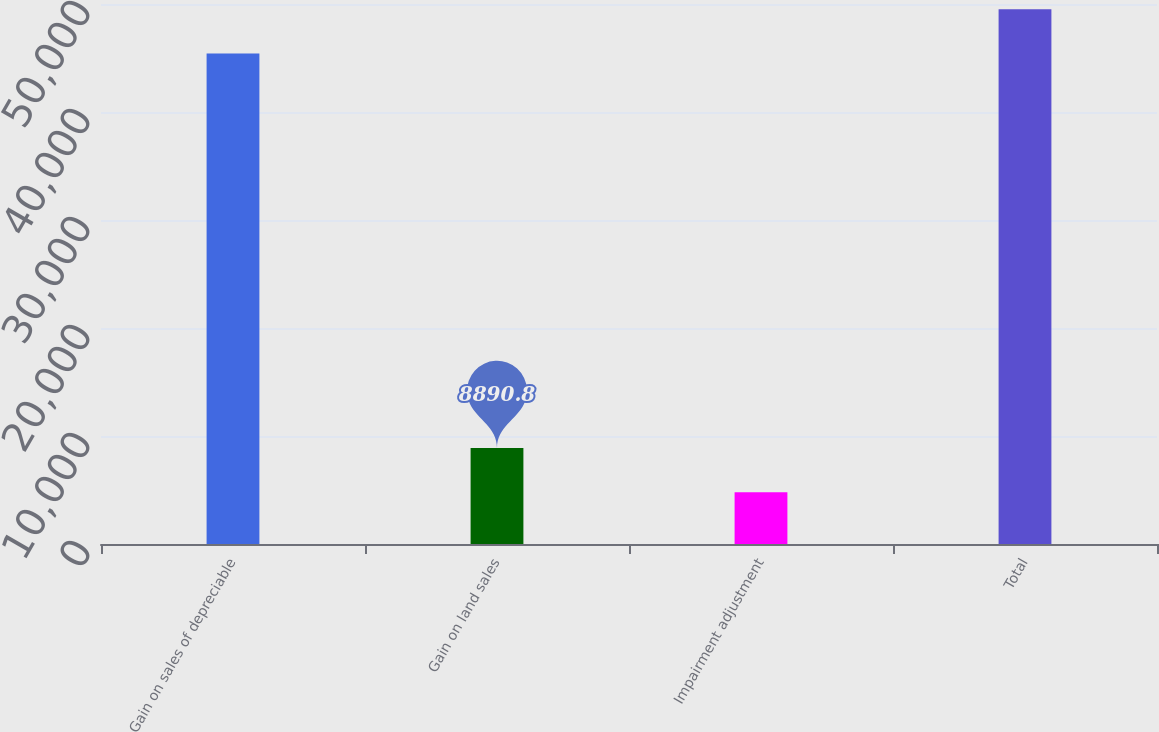Convert chart. <chart><loc_0><loc_0><loc_500><loc_500><bar_chart><fcel>Gain on sales of depreciable<fcel>Gain on land sales<fcel>Impairment adjustment<fcel>Total<nl><fcel>45428<fcel>8890.8<fcel>4800<fcel>49518.8<nl></chart> 